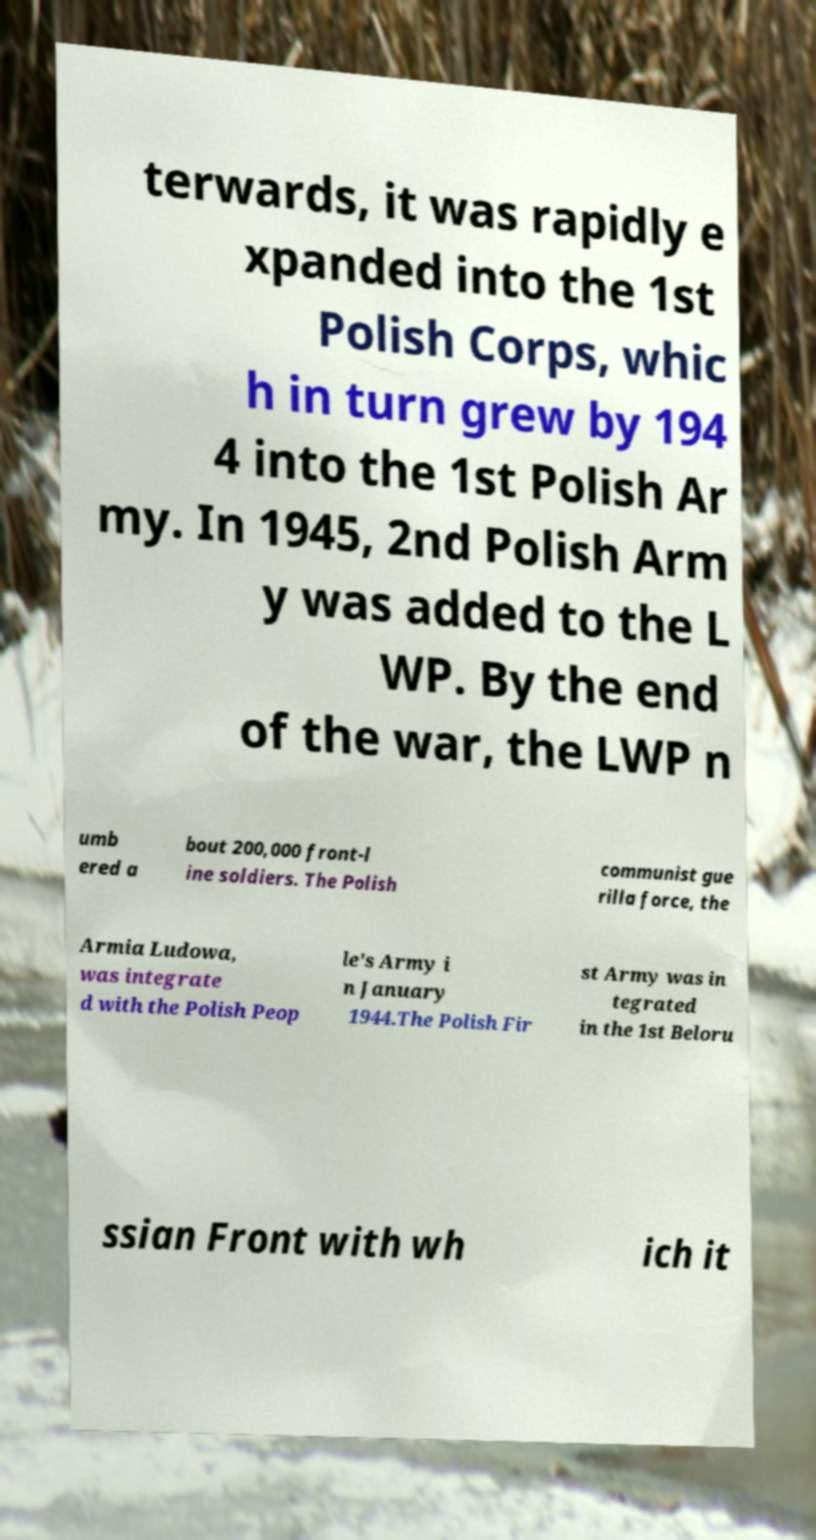Please read and relay the text visible in this image. What does it say? terwards, it was rapidly e xpanded into the 1st Polish Corps, whic h in turn grew by 194 4 into the 1st Polish Ar my. In 1945, 2nd Polish Arm y was added to the L WP. By the end of the war, the LWP n umb ered a bout 200,000 front-l ine soldiers. The Polish communist gue rilla force, the Armia Ludowa, was integrate d with the Polish Peop le's Army i n January 1944.The Polish Fir st Army was in tegrated in the 1st Beloru ssian Front with wh ich it 